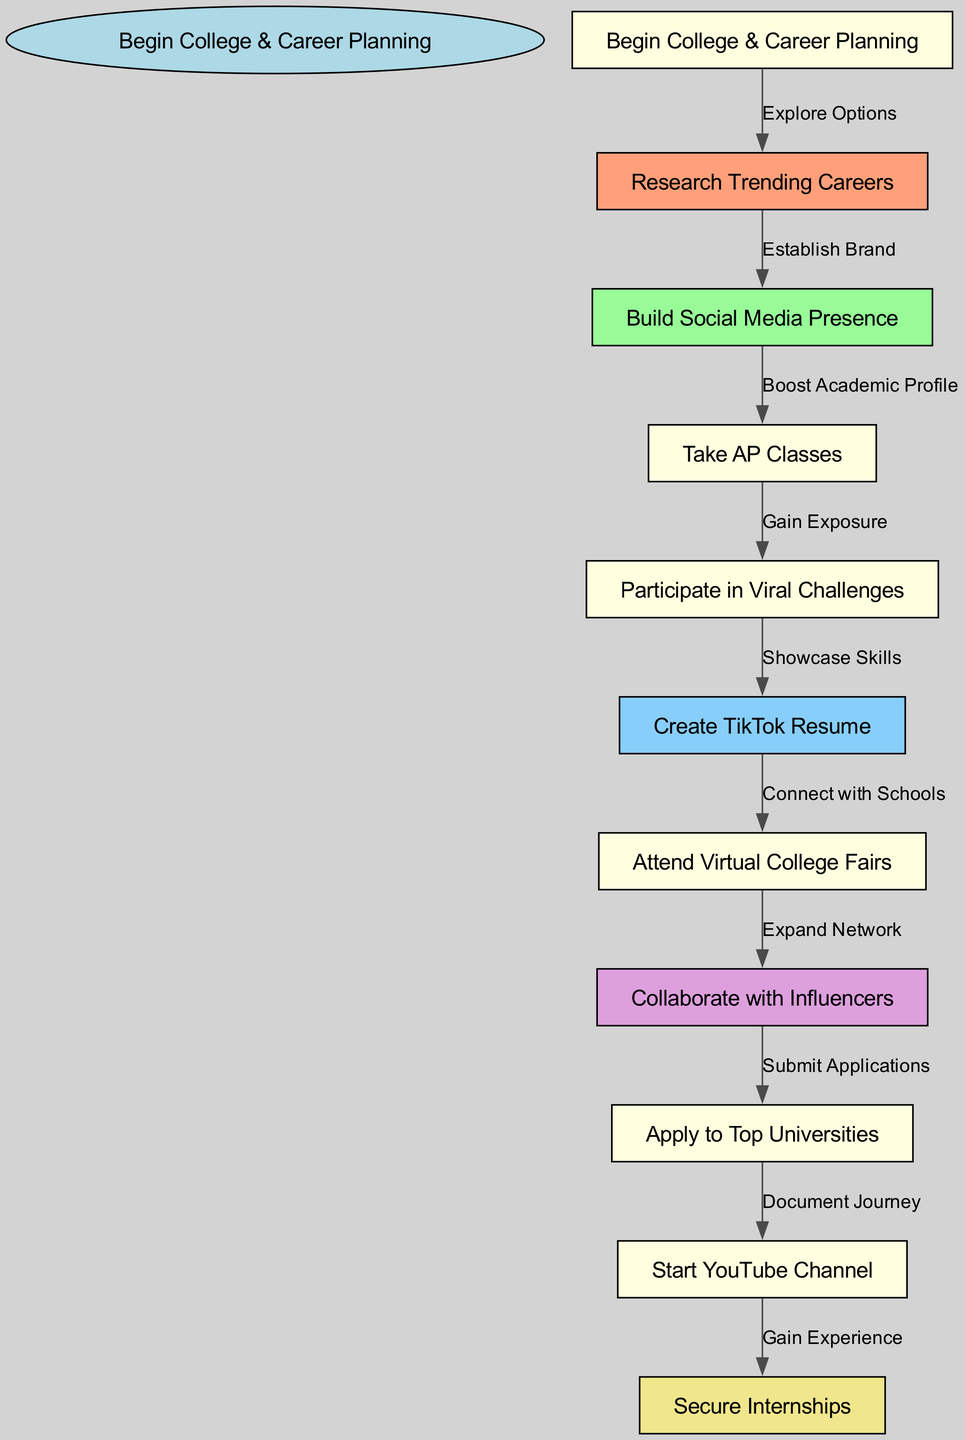What is the starting point of the College & Career Planning? The starting point is clearly indicated as "Begin College & Career Planning" in the diagram, where the pathway starts its flow.
Answer: Begin College & Career Planning How many nodes are there in the diagram? By counting all individual steps from the start to the end, including the starting point and all subsequent nodes, there are a total of 10 nodes.
Answer: 10 What node follows "Research Trending Careers"? The diagram shows the flow from "Research Trending Careers" directly to "Build Social Media Presence," indicating this relationship clearly as the next step.
Answer: Build Social Media Presence What is the relationship between "Attend Virtual College Fairs" and "Collaborate with Influencers"? "Attend Virtual College Fairs" connects to "Collaborate with Influencers," as indicated in the diagram; this means that after attending the fairs, the next step is to collaborate.
Answer: Expand Network What is the final step in the College & Career Planning process? The last node in the pathway after following all previous steps is "Secure Internships," which concludes this mapped out journey.
Answer: Secure Internships What color is the node for "Create TikTok Resume"? The distinct coloring in the diagram shows that the node "Create TikTok Resume" is represented in light sky blue, highlighting its role in the process.
Answer: Light Sky Blue Which two nodes are connected by the label "Gain Exposure"? The diagram specifies that "Participate in Viral Challenges" is connected to "Create TikTok Resume," with the relationship explicitly marked as "Gain Exposure" indicating the flow between these activities.
Answer: Participate in Viral Challenges and Create TikTok Resume What node directly leads to applying to universities? The pathway detail reveals that "Collaborate with Influencers" is the direct precursor to the "Apply to Top Universities" step, linking these two activities.
Answer: Apply to Top Universities What action is suggested after "Start YouTube Channel"? According to the pathway, the action that follows the "Start YouTube Channel" node is "Secure Internships," marking this as the next logical step for career development.
Answer: Secure Internships 